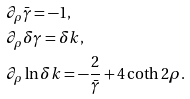<formula> <loc_0><loc_0><loc_500><loc_500>& \partial _ { \rho } \bar { \gamma } = - 1 , \\ & \partial _ { \rho } \delta \gamma = \delta k , \\ & \partial _ { \rho } \ln \delta k = - \frac { 2 } { \bar { \gamma } } + 4 \coth 2 \rho .</formula> 